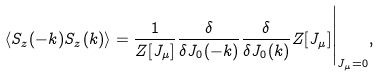Convert formula to latex. <formula><loc_0><loc_0><loc_500><loc_500>\langle S _ { z } ( - k ) S _ { z } ( k ) \rangle = \frac { 1 } { Z [ J _ { \mu } ] } \frac { \delta } { \delta J _ { 0 } ( - k ) } \frac { \delta } { \delta J _ { 0 } ( k ) } Z [ J _ { \mu } ] \Big | _ { J _ { \mu } = 0 } ,</formula> 